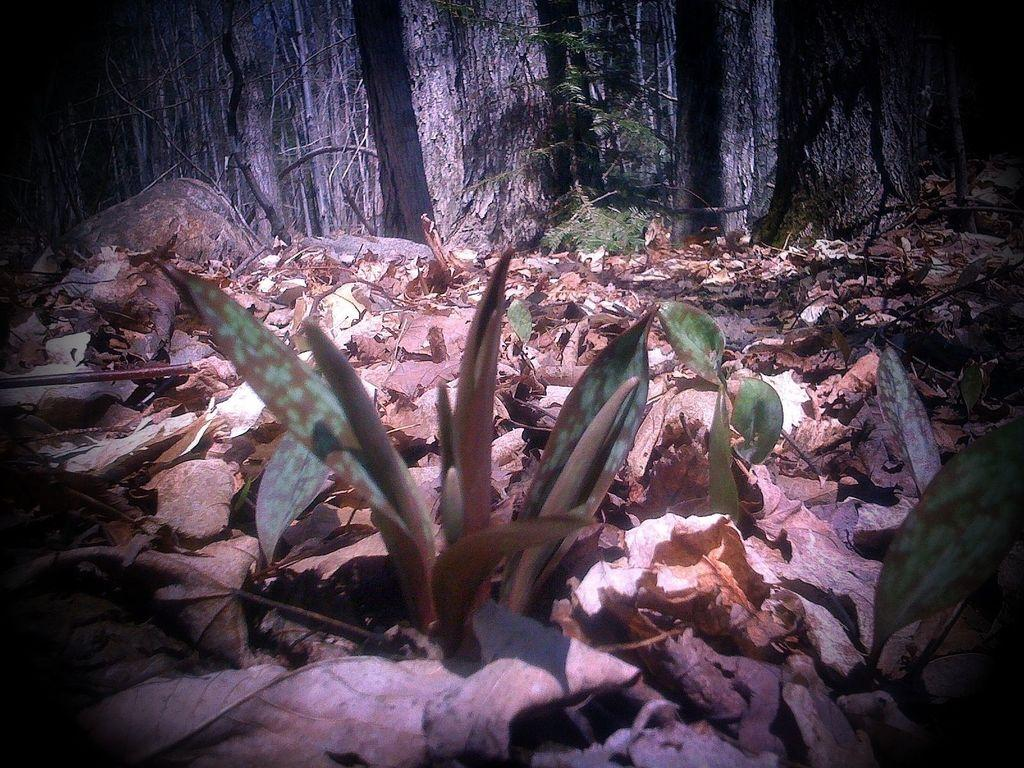What type of vegetation is present in the image? The image contains leaves. What can be seen in the background of the image? There are trees in the background of the image. What type of soda is being served at the protest in the image? There is no protest or soda present in the image; it only contains leaves and trees in the background. 